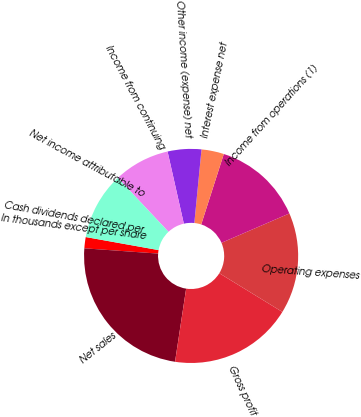Convert chart. <chart><loc_0><loc_0><loc_500><loc_500><pie_chart><fcel>In thousands except per share<fcel>Net sales<fcel>Gross profit<fcel>Operating expenses<fcel>Income from operations (1)<fcel>Interest expense net<fcel>Other income (expense) net<fcel>Income from continuing<fcel>Net income attributable to<fcel>Cash dividends declared per<nl><fcel>1.69%<fcel>23.73%<fcel>18.64%<fcel>15.25%<fcel>13.56%<fcel>3.39%<fcel>5.08%<fcel>8.47%<fcel>10.17%<fcel>0.0%<nl></chart> 